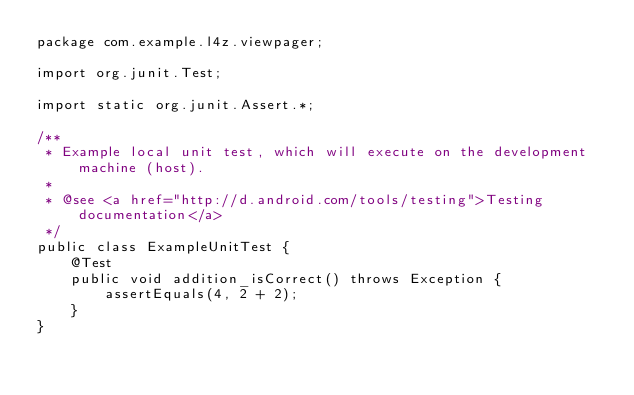<code> <loc_0><loc_0><loc_500><loc_500><_Java_>package com.example.l4z.viewpager;

import org.junit.Test;

import static org.junit.Assert.*;

/**
 * Example local unit test, which will execute on the development machine (host).
 *
 * @see <a href="http://d.android.com/tools/testing">Testing documentation</a>
 */
public class ExampleUnitTest {
    @Test
    public void addition_isCorrect() throws Exception {
        assertEquals(4, 2 + 2);
    }
}</code> 